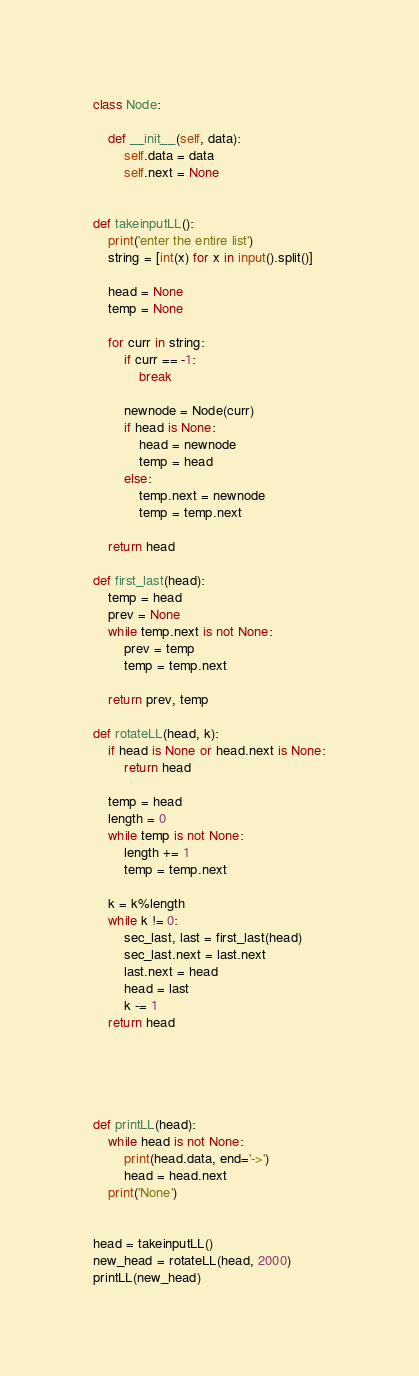Convert code to text. <code><loc_0><loc_0><loc_500><loc_500><_Python_>class Node:

    def __init__(self, data):
        self.data = data
        self.next = None


def takeinputLL():
    print('enter the entire list')
    string = [int(x) for x in input().split()]

    head = None
    temp = None

    for curr in string:
        if curr == -1:
            break
        
        newnode = Node(curr)
        if head is None:
            head = newnode
            temp = head
        else:
            temp.next = newnode
            temp = temp.next

    return head

def first_last(head):
    temp = head
    prev = None
    while temp.next is not None:
        prev = temp
        temp = temp.next

    return prev, temp

def rotateLL(head, k):
    if head is None or head.next is None:
        return head

    temp = head
    length = 0
    while temp is not None:
        length += 1
        temp = temp.next

    k = k%length
    while k != 0:
        sec_last, last = first_last(head)
        sec_last.next = last.next
        last.next = head
        head = last
        k -= 1
    return head





def printLL(head):
    while head is not None:
        print(head.data, end='->')
        head = head.next
    print('None')


head = takeinputLL()
new_head = rotateLL(head, 2000)
printLL(new_head)</code> 